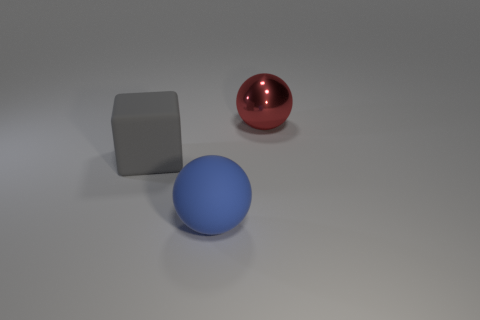There is a blue object that is the same material as the big gray block; what is its size?
Offer a terse response. Large. There is a red object; is it the same size as the ball that is left of the red object?
Ensure brevity in your answer.  Yes. There is a large thing that is on the right side of the large block and to the left of the large shiny object; what is its color?
Offer a terse response. Blue. How many things are blue rubber spheres that are right of the gray rubber cube or large spheres in front of the red sphere?
Offer a terse response. 1. There is a object in front of the object that is to the left of the object in front of the large cube; what is its color?
Your answer should be compact. Blue. Is there a small brown object of the same shape as the blue thing?
Your response must be concise. No. What number of big red blocks are there?
Your answer should be compact. 0. The big gray object is what shape?
Your answer should be compact. Cube. How many gray rubber things are the same size as the shiny ball?
Your answer should be compact. 1. Does the large red thing have the same shape as the gray thing?
Your response must be concise. No. 